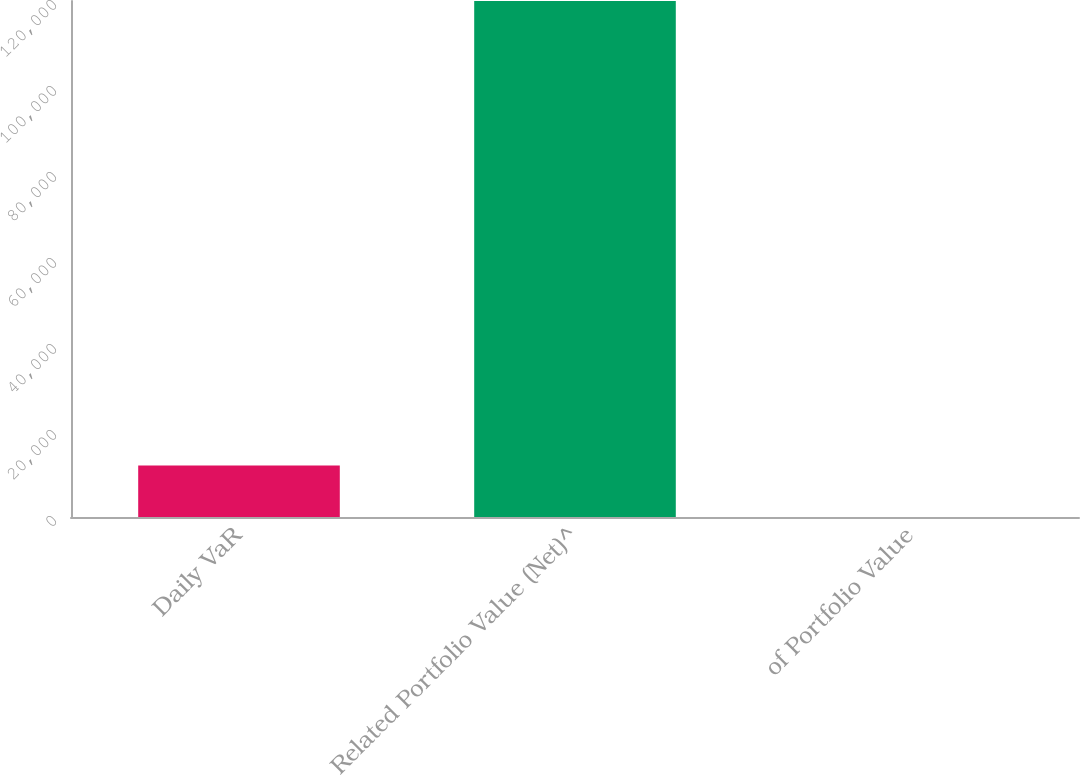<chart> <loc_0><loc_0><loc_500><loc_500><bar_chart><fcel>Daily VaR<fcel>Related Portfolio Value (Net)^<fcel>of Portfolio Value<nl><fcel>11999.4<fcel>119986<fcel>0.91<nl></chart> 